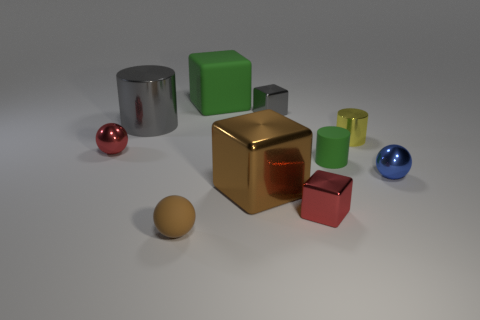Can you tell me the material that the shiny sphere appears to be made of? The sphere on the left side exudes a reflective quality that suggests it's made of a polished metal, possibly chrome or steel, given its mirror-like appearance. 